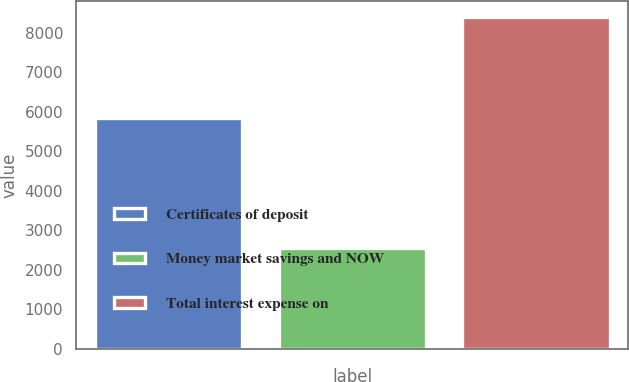Convert chart to OTSL. <chart><loc_0><loc_0><loc_500><loc_500><bar_chart><fcel>Certificates of deposit<fcel>Money market savings and NOW<fcel>Total interest expense on<nl><fcel>5839<fcel>2543<fcel>8382<nl></chart> 